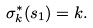Convert formula to latex. <formula><loc_0><loc_0><loc_500><loc_500>\sigma _ { k } ^ { \ast } ( s _ { 1 } ) = k .</formula> 